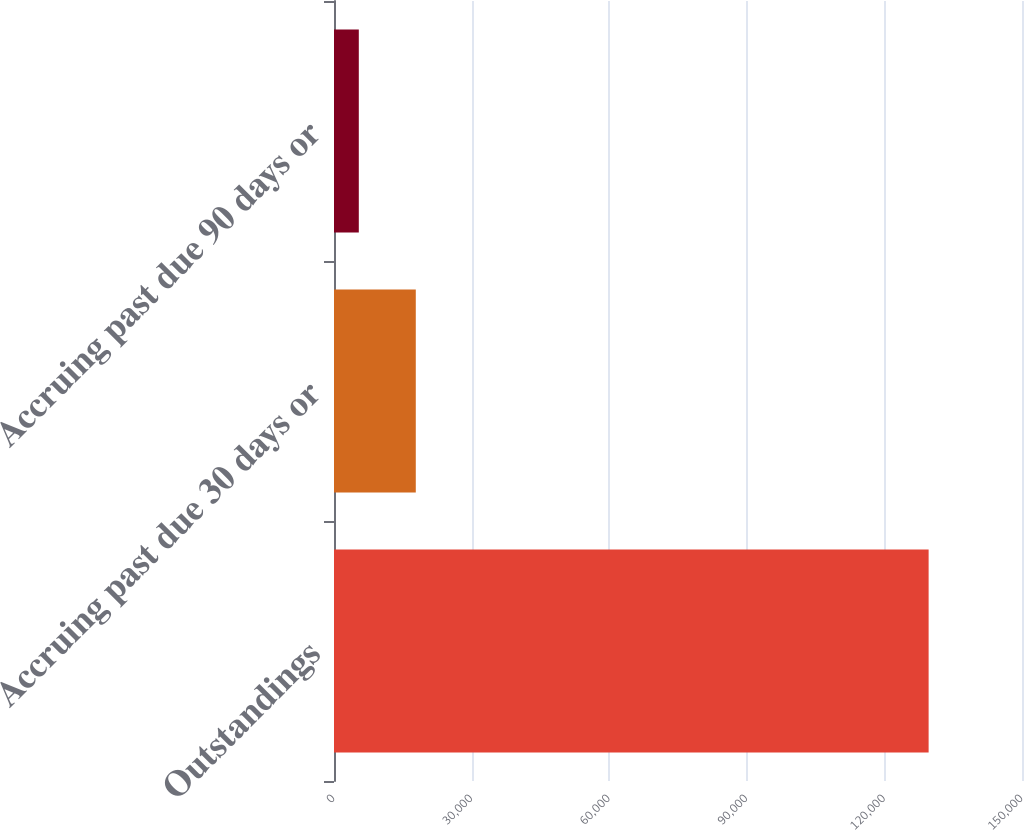Convert chart to OTSL. <chart><loc_0><loc_0><loc_500><loc_500><bar_chart><fcel>Outstandings<fcel>Accruing past due 30 days or<fcel>Accruing past due 90 days or<nl><fcel>129642<fcel>17831.4<fcel>5408<nl></chart> 